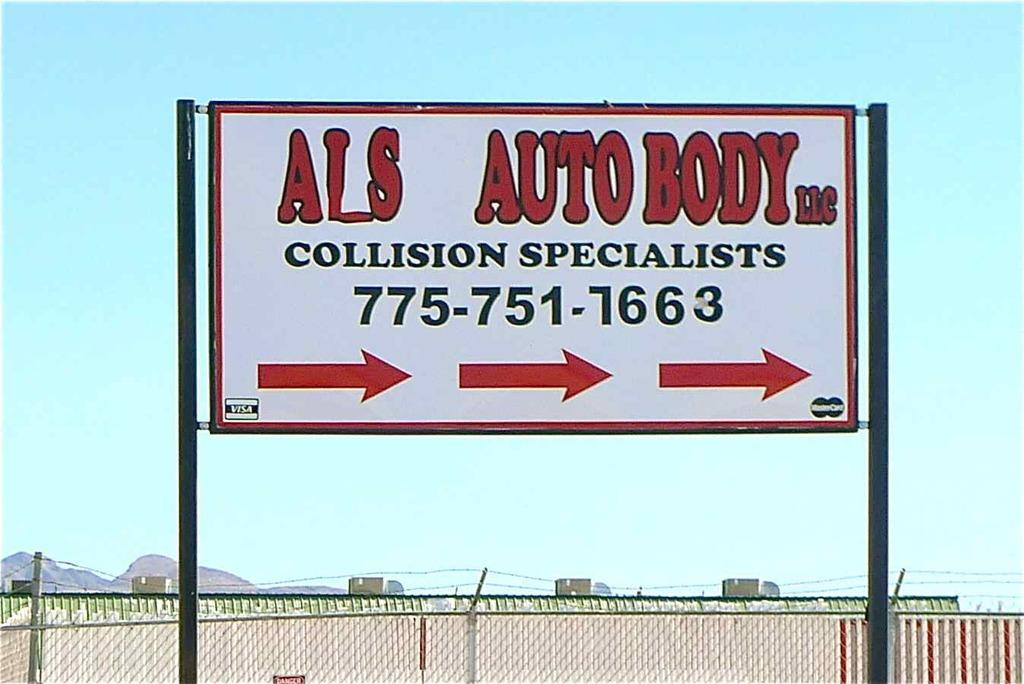<image>
Present a compact description of the photo's key features. Sign with Als Auto body collision specialist and a phone number 